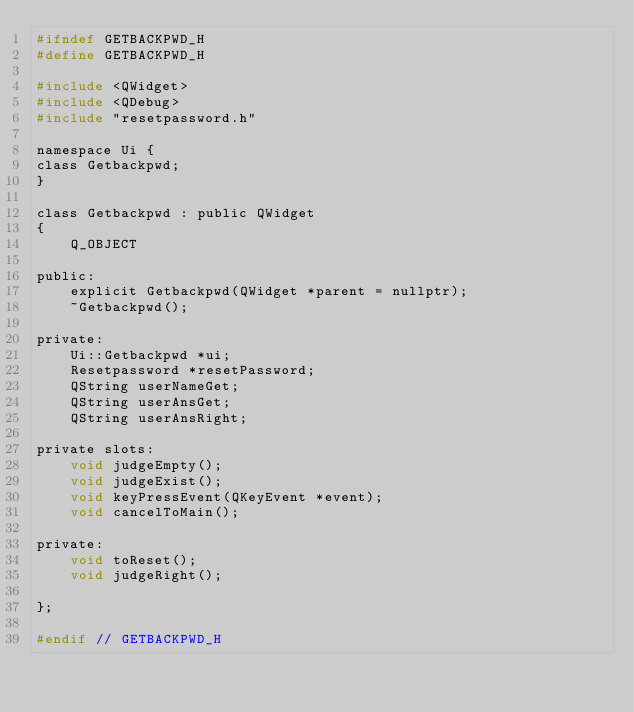Convert code to text. <code><loc_0><loc_0><loc_500><loc_500><_C_>#ifndef GETBACKPWD_H
#define GETBACKPWD_H

#include <QWidget>
#include <QDebug>
#include "resetpassword.h"

namespace Ui {
class Getbackpwd;
}

class Getbackpwd : public QWidget
{
    Q_OBJECT

public:
    explicit Getbackpwd(QWidget *parent = nullptr);
    ~Getbackpwd();

private:
    Ui::Getbackpwd *ui;
    Resetpassword *resetPassword;
    QString userNameGet;
    QString userAnsGet;
    QString userAnsRight;

private slots:
    void judgeEmpty();
    void judgeExist();
    void keyPressEvent(QKeyEvent *event);
    void cancelToMain();

private:    
    void toReset();
    void judgeRight();

};

#endif // GETBACKPWD_H
</code> 